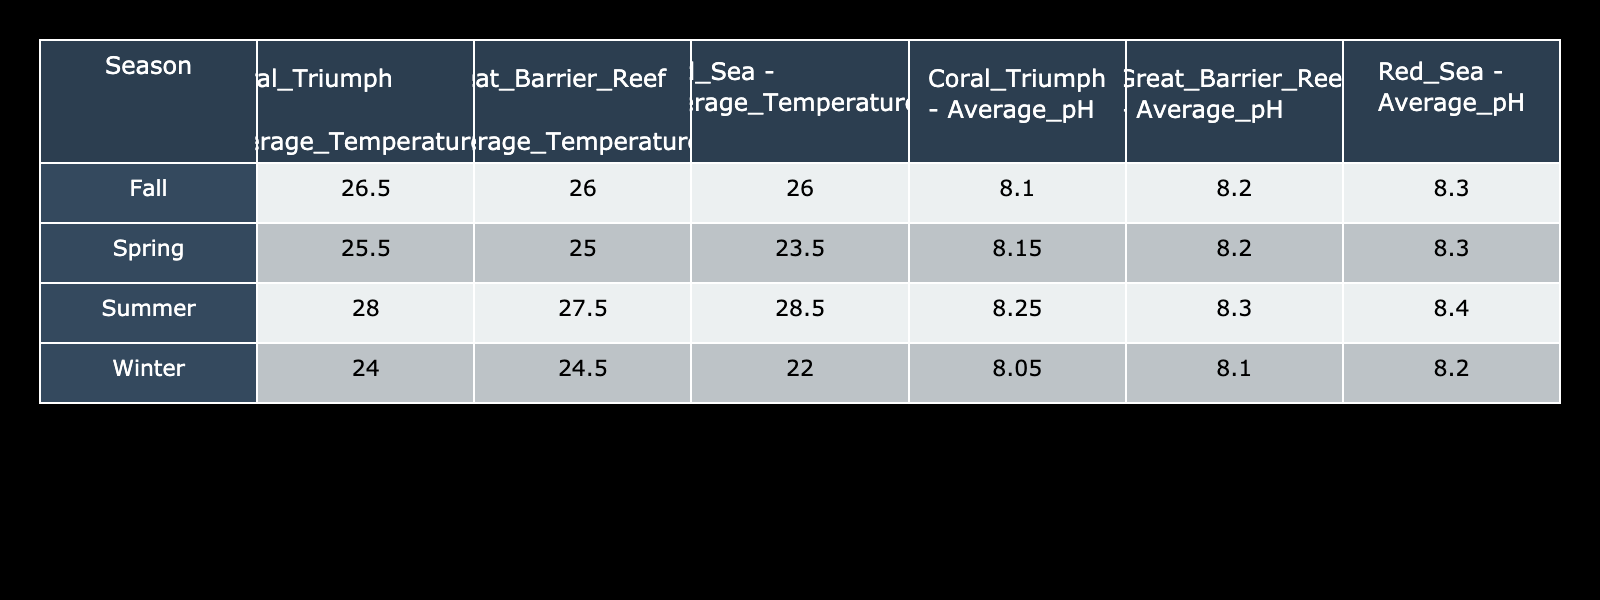What is the average temperature in the Red Sea during summer? The table shows the average temperature in the Red Sea during summer is 28.5°C
Answer: 28.5°C Which location has the highest average pH during winter? According to the table, the Red Sea has the highest average pH during winter at 8.2
Answer: 8.2 What is the temperature difference between the Great Barrier Reef in summer and in fall? The average temperature in the Great Barrier Reef during summer is 27.5°C and in fall is 26.0°C. The difference is 27.5°C - 26.0°C = 1.5°C
Answer: 1.5°C Does Coral Triumph's average pH increase from winter to spring? Based on the table, Coral Triumph's average pH in winter is 8.05 and in spring it is 8.15, showing an increase
Answer: Yes Which season has the highest average temperature among all locations? Comparing all the averages, summer has the highest temperature with 28.5°C in the Red Sea, which is greater than the summer temperatures in other locations
Answer: Summer 